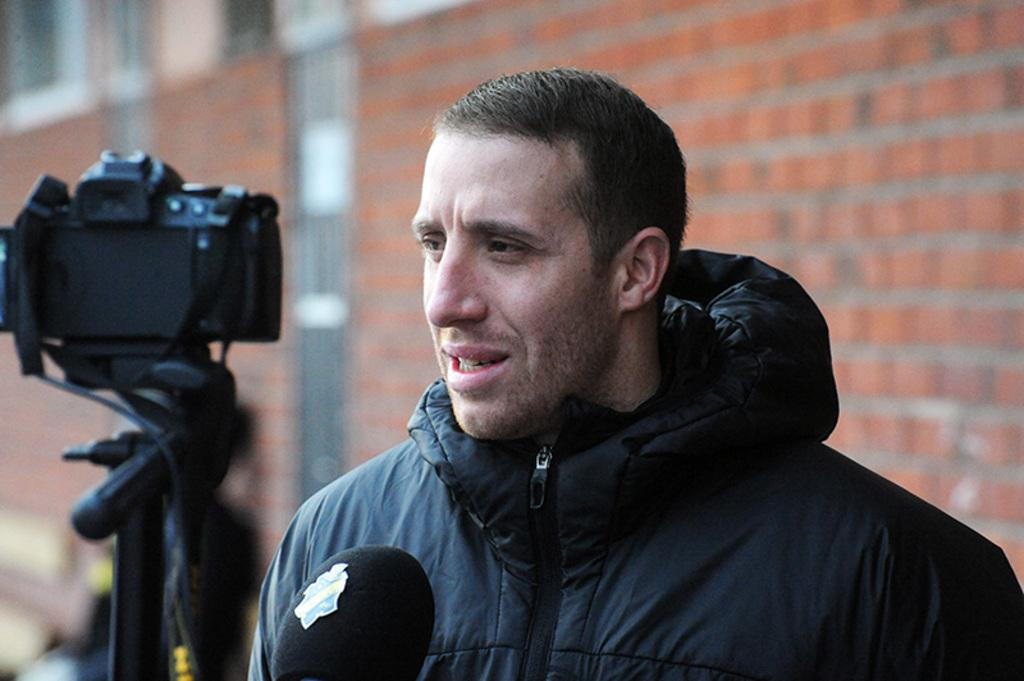Who is the main subject in the foreground of the image? There is a man in the foreground of the image. What is the man wearing in the image? The man is wearing a black jacket. What object is in front of the man in the image? There is a microphone in front of the man. What can be seen in the background of the image? There is a camera on a stand and a wall in the background of the image. How many wings are visible on the man in the image? There are no wings visible on the man in the image. What type of design can be seen on the man's feet in the image? There is no information about the man's feet or any design on them in the image. 